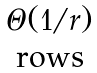<formula> <loc_0><loc_0><loc_500><loc_500>\begin{matrix} \Theta ( 1 / r ) \\ \text {rows} \end{matrix}</formula> 